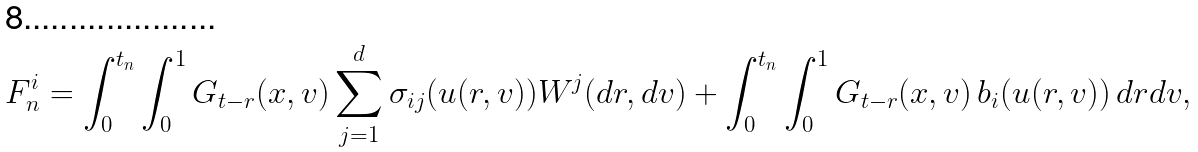<formula> <loc_0><loc_0><loc_500><loc_500>F _ { n } ^ { i } = \int _ { 0 } ^ { t _ { n } } \int _ { 0 } ^ { 1 } G _ { t - r } ( x , v ) \sum _ { j = 1 } ^ { d } \sigma _ { i j } ( u ( r , v ) ) W ^ { j } ( d r , d v ) + \int _ { 0 } ^ { t _ { n } } \int _ { 0 } ^ { 1 } G _ { t - r } ( x , v ) \, b _ { i } ( u ( r , v ) ) \, d r d v ,</formula> 